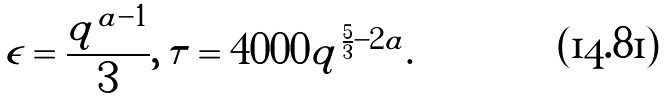<formula> <loc_0><loc_0><loc_500><loc_500>\epsilon = \frac { q ^ { a - 1 } } { 3 } , \, \tau = 4 0 0 0 q ^ { \frac { 5 } { 3 } - 2 a } .</formula> 